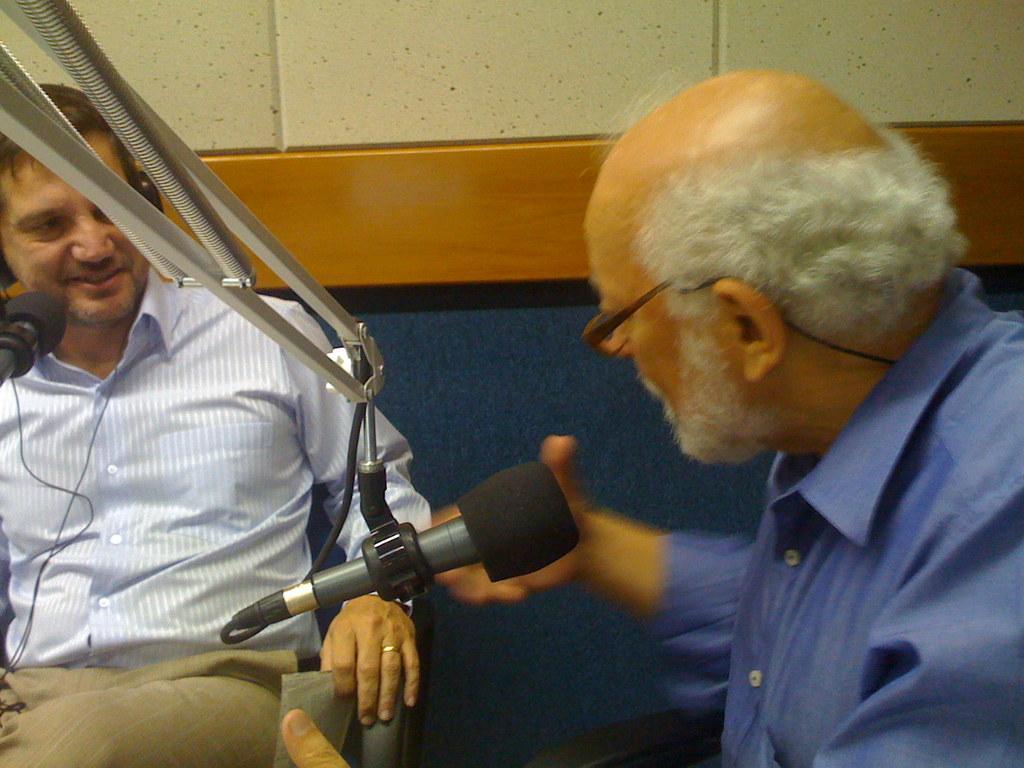Can you describe this image briefly? In this image we can see two persons sitting. In the foreground we can see a mic with stand. On the left side, we can see a person wearing headphones. Behind the person we can see a wall with tiles. 